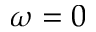Convert formula to latex. <formula><loc_0><loc_0><loc_500><loc_500>\omega = 0</formula> 